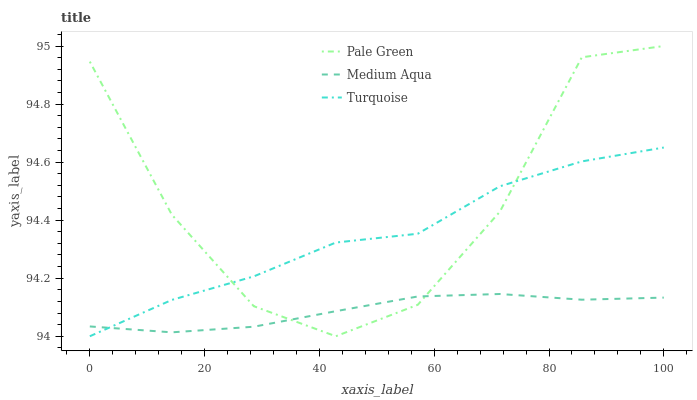Does Medium Aqua have the minimum area under the curve?
Answer yes or no. Yes. Does Pale Green have the maximum area under the curve?
Answer yes or no. Yes. Does Pale Green have the minimum area under the curve?
Answer yes or no. No. Does Medium Aqua have the maximum area under the curve?
Answer yes or no. No. Is Medium Aqua the smoothest?
Answer yes or no. Yes. Is Pale Green the roughest?
Answer yes or no. Yes. Is Pale Green the smoothest?
Answer yes or no. No. Is Medium Aqua the roughest?
Answer yes or no. No. Does Pale Green have the lowest value?
Answer yes or no. No. Does Medium Aqua have the highest value?
Answer yes or no. No. 